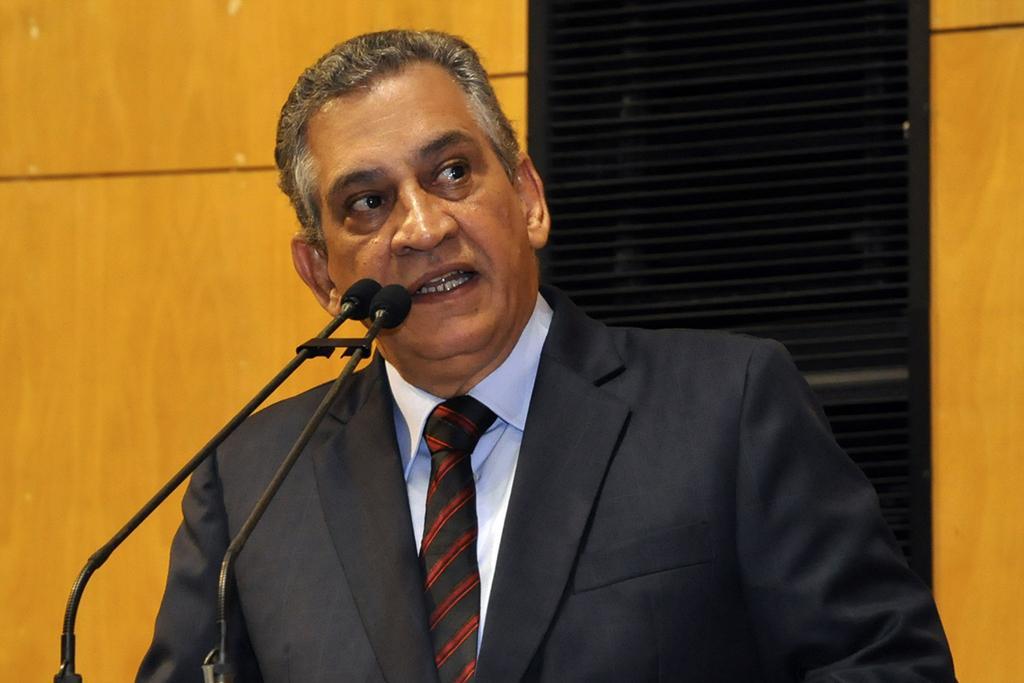Can you describe this image briefly? In this image, we can see a person and some microphones. We can see the wall and a black colored object. 